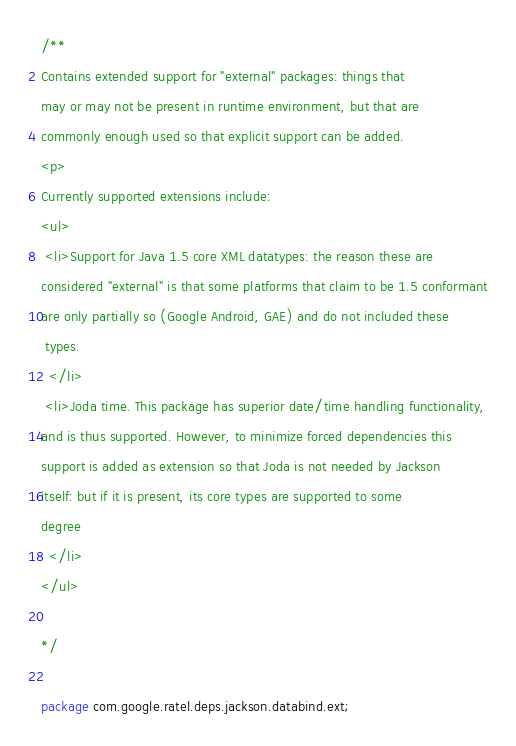Convert code to text. <code><loc_0><loc_0><loc_500><loc_500><_Java_>/**
Contains extended support for "external" packages: things that
may or may not be present in runtime environment, but that are
commonly enough used so that explicit support can be added.
<p>
Currently supported extensions include:
<ul>
 <li>Support for Java 1.5 core XML datatypes: the reason these are
considered "external" is that some platforms that claim to be 1.5 conformant
are only partially so (Google Android, GAE) and do not included these
 types.
  </li>
 <li>Joda time. This package has superior date/time handling functionality,
and is thus supported. However, to minimize forced dependencies this
support is added as extension so that Joda is not needed by Jackson
itself: but if it is present, its core types are supported to some
degree
  </li>
</ul>

*/

package com.google.ratel.deps.jackson.databind.ext;
</code> 